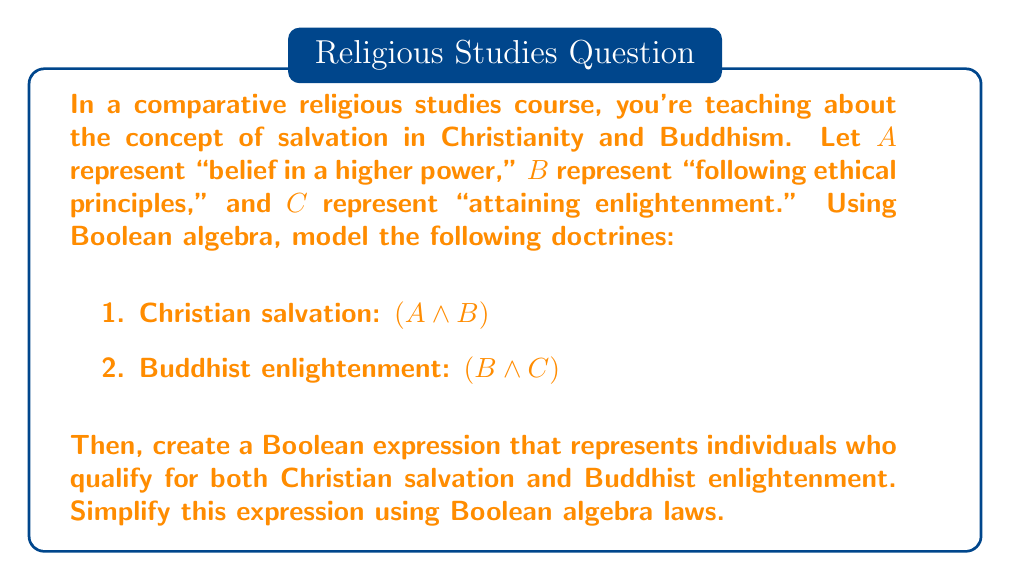Can you answer this question? Let's approach this step-by-step:

1. Christian salvation is represented as: $A \cdot B$
2. Buddhist enlightenment is represented as: $B \cdot C$

To find individuals who qualify for both, we need to use the AND operation between these two expressions:

$$(A \cdot B) \cdot (B \cdot C)$$

Now, let's simplify this expression using Boolean algebra laws:

1. Apply the associative law of multiplication:
   $$(A \cdot B) \cdot (B \cdot C) = A \cdot (B \cdot B) \cdot C$$

2. Apply the idempotent law ($B \cdot B = B$):
   $$A \cdot (B \cdot B) \cdot C = A \cdot B \cdot C$$

This simplified expression, $A \cdot B \cdot C$, represents individuals who:
- Believe in a higher power (A)
- Follow ethical principles (B)
- Attain enlightenment (C)

In the context of comparative religious studies, this result suggests that to satisfy both Christian salvation and Buddhist enlightenment criteria, one would need to believe in a higher power, follow ethical principles, and attain enlightenment.
Answer: $A \cdot B \cdot C$ 